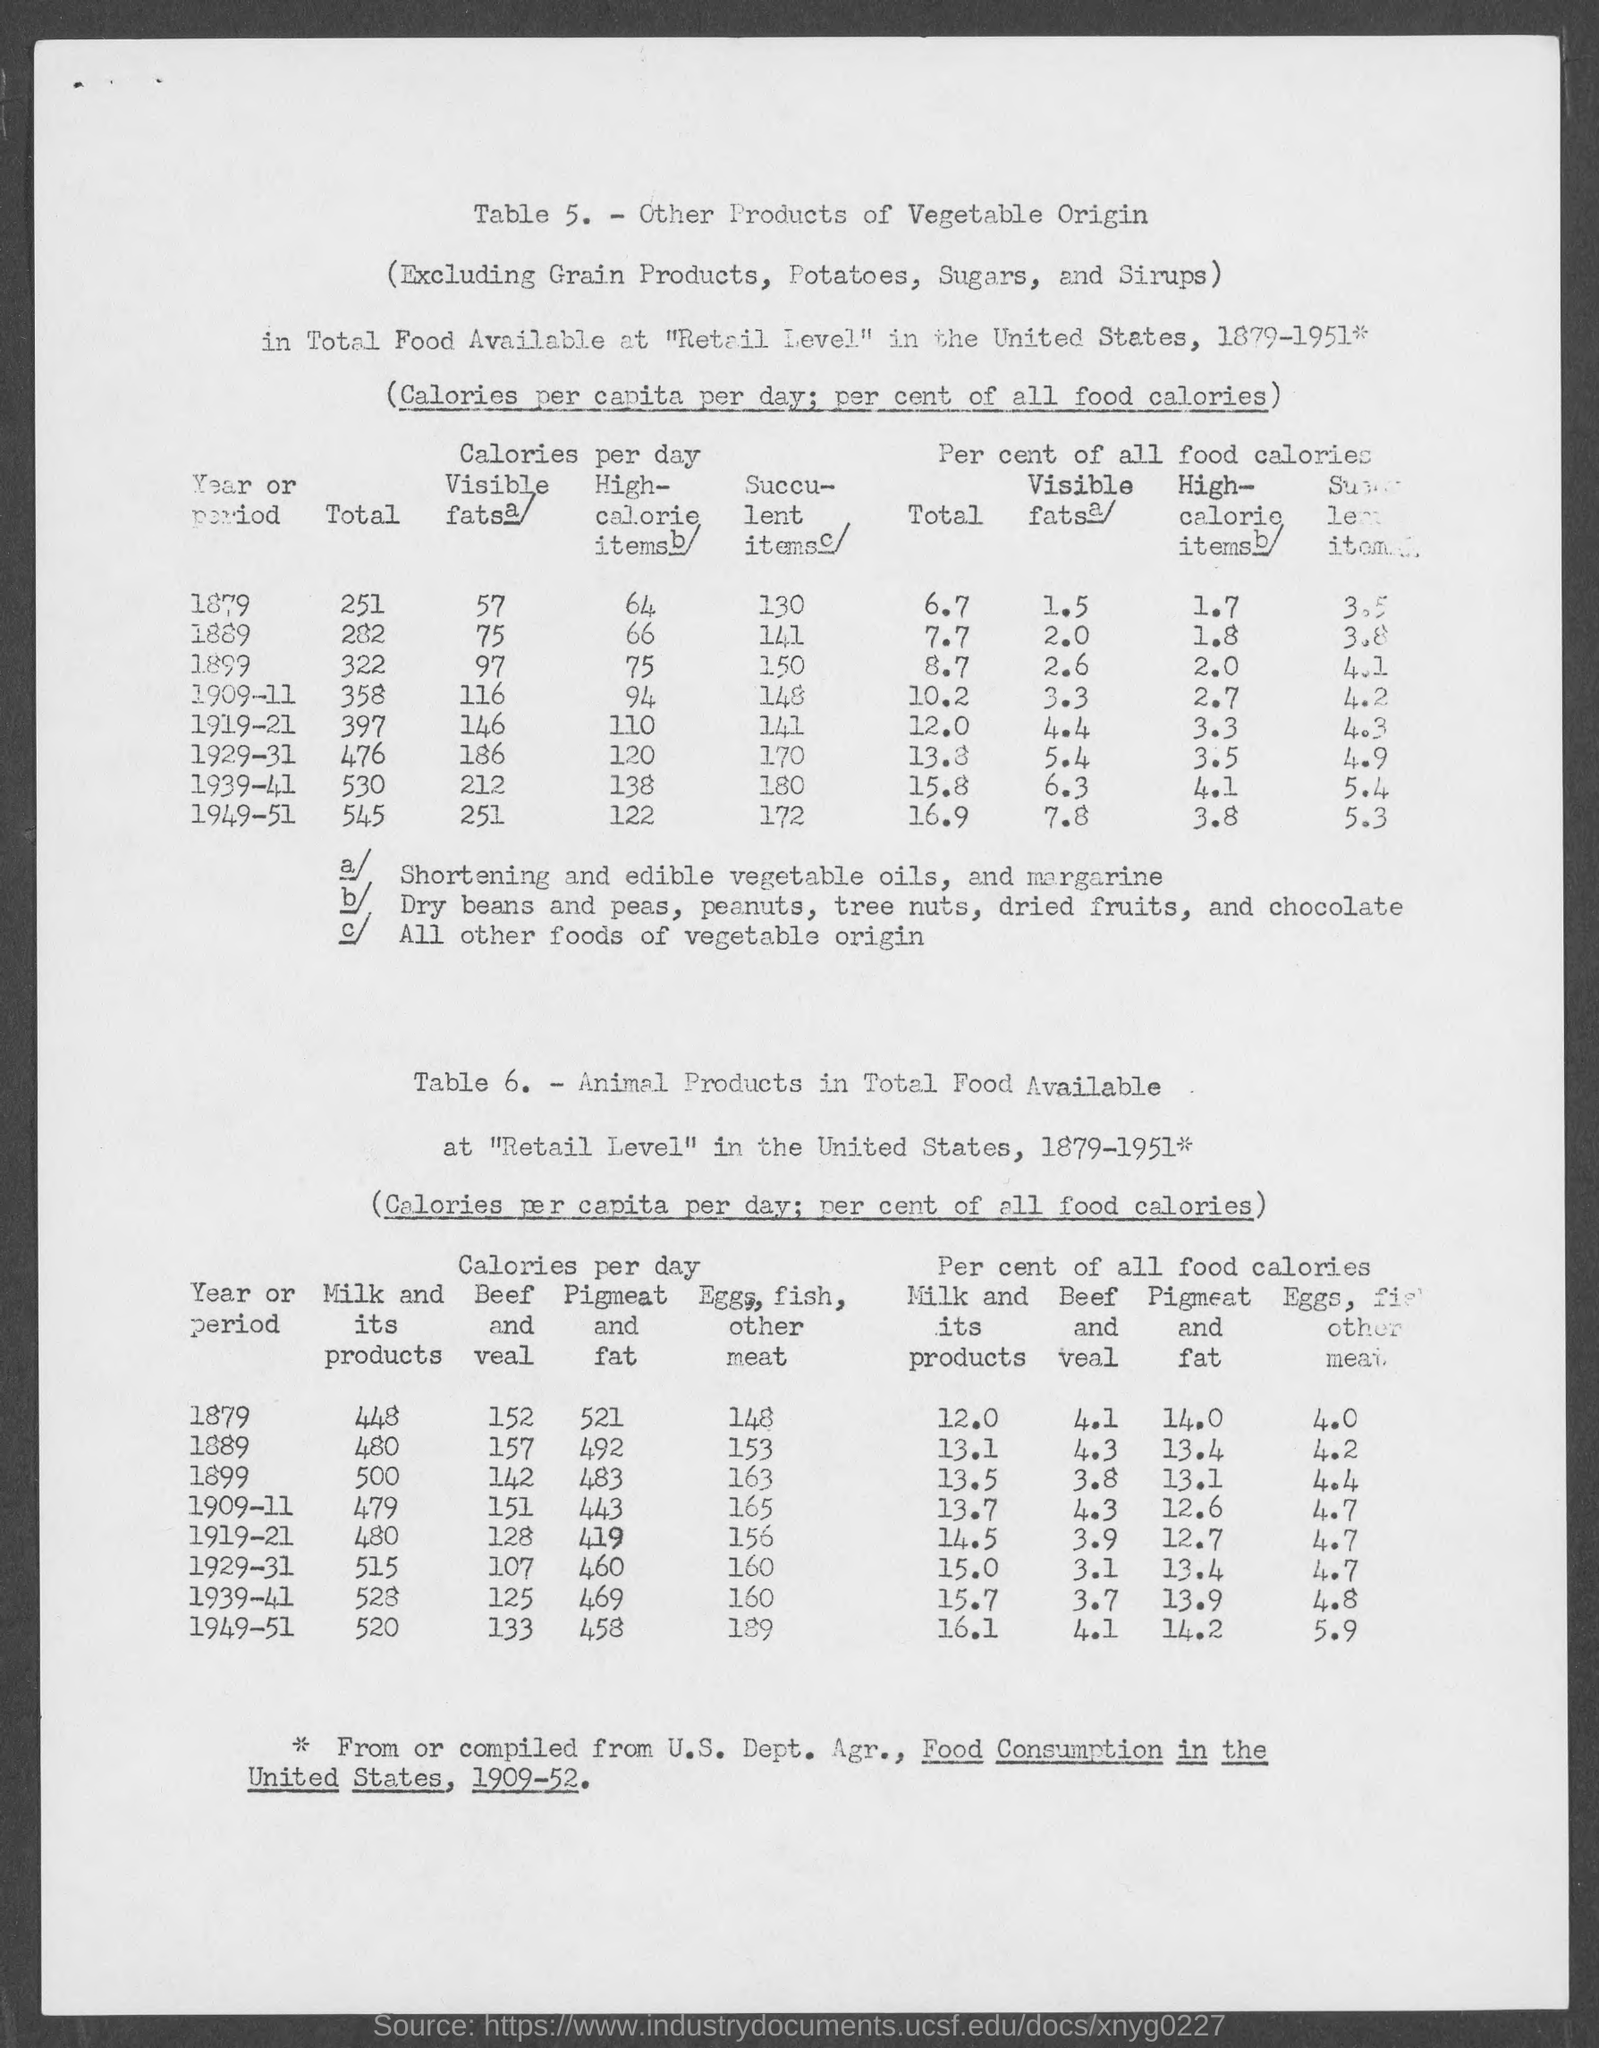What is the number of the first table?
Keep it short and to the point. 5. What is the number of the second table?
Give a very brief answer. Table 6. 